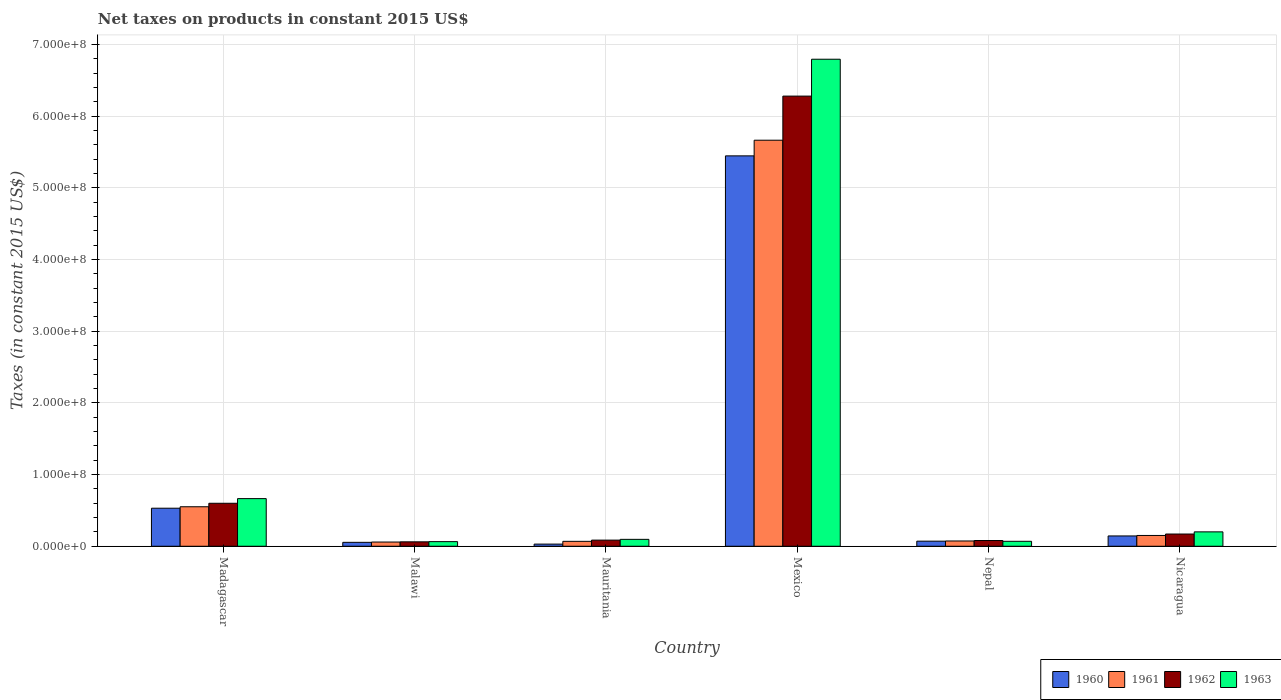How many groups of bars are there?
Your answer should be compact. 6. Are the number of bars per tick equal to the number of legend labels?
Offer a very short reply. Yes. How many bars are there on the 2nd tick from the left?
Give a very brief answer. 4. How many bars are there on the 5th tick from the right?
Keep it short and to the point. 4. What is the label of the 6th group of bars from the left?
Your answer should be compact. Nicaragua. In how many cases, is the number of bars for a given country not equal to the number of legend labels?
Give a very brief answer. 0. What is the net taxes on products in 1962 in Mexico?
Offer a terse response. 6.28e+08. Across all countries, what is the maximum net taxes on products in 1962?
Your answer should be compact. 6.28e+08. Across all countries, what is the minimum net taxes on products in 1963?
Offer a terse response. 6.44e+06. In which country was the net taxes on products in 1961 minimum?
Offer a very short reply. Malawi. What is the total net taxes on products in 1962 in the graph?
Ensure brevity in your answer.  7.28e+08. What is the difference between the net taxes on products in 1961 in Madagascar and that in Mexico?
Make the answer very short. -5.11e+08. What is the difference between the net taxes on products in 1961 in Madagascar and the net taxes on products in 1963 in Malawi?
Give a very brief answer. 4.87e+07. What is the average net taxes on products in 1960 per country?
Provide a succinct answer. 1.05e+08. What is the difference between the net taxes on products of/in 1963 and net taxes on products of/in 1960 in Mauritania?
Keep it short and to the point. 6.63e+06. In how many countries, is the net taxes on products in 1963 greater than 540000000 US$?
Ensure brevity in your answer.  1. What is the ratio of the net taxes on products in 1960 in Malawi to that in Mauritania?
Make the answer very short. 1.82. What is the difference between the highest and the second highest net taxes on products in 1962?
Make the answer very short. 4.29e+07. What is the difference between the highest and the lowest net taxes on products in 1961?
Your answer should be very brief. 5.61e+08. In how many countries, is the net taxes on products in 1962 greater than the average net taxes on products in 1962 taken over all countries?
Offer a very short reply. 1. Is it the case that in every country, the sum of the net taxes on products in 1963 and net taxes on products in 1961 is greater than the sum of net taxes on products in 1962 and net taxes on products in 1960?
Make the answer very short. No. What does the 2nd bar from the left in Mauritania represents?
Your answer should be compact. 1961. What is the difference between two consecutive major ticks on the Y-axis?
Make the answer very short. 1.00e+08. How many legend labels are there?
Offer a very short reply. 4. How are the legend labels stacked?
Your answer should be very brief. Horizontal. What is the title of the graph?
Offer a very short reply. Net taxes on products in constant 2015 US$. What is the label or title of the Y-axis?
Give a very brief answer. Taxes (in constant 2015 US$). What is the Taxes (in constant 2015 US$) in 1960 in Madagascar?
Your response must be concise. 5.31e+07. What is the Taxes (in constant 2015 US$) in 1961 in Madagascar?
Offer a very short reply. 5.51e+07. What is the Taxes (in constant 2015 US$) in 1962 in Madagascar?
Your answer should be compact. 6.00e+07. What is the Taxes (in constant 2015 US$) of 1963 in Madagascar?
Give a very brief answer. 6.64e+07. What is the Taxes (in constant 2015 US$) in 1960 in Malawi?
Provide a short and direct response. 5.46e+06. What is the Taxes (in constant 2015 US$) in 1961 in Malawi?
Offer a very short reply. 5.88e+06. What is the Taxes (in constant 2015 US$) in 1962 in Malawi?
Your response must be concise. 6.16e+06. What is the Taxes (in constant 2015 US$) of 1963 in Malawi?
Your answer should be compact. 6.44e+06. What is the Taxes (in constant 2015 US$) in 1960 in Mauritania?
Provide a short and direct response. 3.00e+06. What is the Taxes (in constant 2015 US$) of 1961 in Mauritania?
Ensure brevity in your answer.  6.85e+06. What is the Taxes (in constant 2015 US$) of 1962 in Mauritania?
Give a very brief answer. 8.56e+06. What is the Taxes (in constant 2015 US$) of 1963 in Mauritania?
Offer a very short reply. 9.63e+06. What is the Taxes (in constant 2015 US$) of 1960 in Mexico?
Offer a very short reply. 5.45e+08. What is the Taxes (in constant 2015 US$) of 1961 in Mexico?
Your response must be concise. 5.66e+08. What is the Taxes (in constant 2015 US$) of 1962 in Mexico?
Your response must be concise. 6.28e+08. What is the Taxes (in constant 2015 US$) in 1963 in Mexico?
Your answer should be very brief. 6.79e+08. What is the Taxes (in constant 2015 US$) in 1960 in Nepal?
Your answer should be very brief. 7.09e+06. What is the Taxes (in constant 2015 US$) of 1961 in Nepal?
Give a very brief answer. 7.35e+06. What is the Taxes (in constant 2015 US$) in 1962 in Nepal?
Provide a succinct answer. 8.01e+06. What is the Taxes (in constant 2015 US$) of 1963 in Nepal?
Offer a very short reply. 6.89e+06. What is the Taxes (in constant 2015 US$) in 1960 in Nicaragua?
Offer a very short reply. 1.44e+07. What is the Taxes (in constant 2015 US$) in 1961 in Nicaragua?
Your answer should be very brief. 1.51e+07. What is the Taxes (in constant 2015 US$) in 1962 in Nicaragua?
Your response must be concise. 1.71e+07. What is the Taxes (in constant 2015 US$) of 1963 in Nicaragua?
Your response must be concise. 2.01e+07. Across all countries, what is the maximum Taxes (in constant 2015 US$) in 1960?
Your response must be concise. 5.45e+08. Across all countries, what is the maximum Taxes (in constant 2015 US$) of 1961?
Keep it short and to the point. 5.66e+08. Across all countries, what is the maximum Taxes (in constant 2015 US$) of 1962?
Your response must be concise. 6.28e+08. Across all countries, what is the maximum Taxes (in constant 2015 US$) of 1963?
Give a very brief answer. 6.79e+08. Across all countries, what is the minimum Taxes (in constant 2015 US$) in 1960?
Make the answer very short. 3.00e+06. Across all countries, what is the minimum Taxes (in constant 2015 US$) in 1961?
Your answer should be compact. 5.88e+06. Across all countries, what is the minimum Taxes (in constant 2015 US$) of 1962?
Offer a very short reply. 6.16e+06. Across all countries, what is the minimum Taxes (in constant 2015 US$) in 1963?
Your answer should be compact. 6.44e+06. What is the total Taxes (in constant 2015 US$) of 1960 in the graph?
Offer a very short reply. 6.28e+08. What is the total Taxes (in constant 2015 US$) of 1961 in the graph?
Ensure brevity in your answer.  6.57e+08. What is the total Taxes (in constant 2015 US$) of 1962 in the graph?
Make the answer very short. 7.28e+08. What is the total Taxes (in constant 2015 US$) in 1963 in the graph?
Provide a succinct answer. 7.89e+08. What is the difference between the Taxes (in constant 2015 US$) of 1960 in Madagascar and that in Malawi?
Your answer should be compact. 4.76e+07. What is the difference between the Taxes (in constant 2015 US$) in 1961 in Madagascar and that in Malawi?
Provide a short and direct response. 4.92e+07. What is the difference between the Taxes (in constant 2015 US$) of 1962 in Madagascar and that in Malawi?
Your response must be concise. 5.38e+07. What is the difference between the Taxes (in constant 2015 US$) in 1963 in Madagascar and that in Malawi?
Your answer should be compact. 6.00e+07. What is the difference between the Taxes (in constant 2015 US$) of 1960 in Madagascar and that in Mauritania?
Keep it short and to the point. 5.01e+07. What is the difference between the Taxes (in constant 2015 US$) of 1961 in Madagascar and that in Mauritania?
Offer a very short reply. 4.82e+07. What is the difference between the Taxes (in constant 2015 US$) in 1962 in Madagascar and that in Mauritania?
Offer a very short reply. 5.14e+07. What is the difference between the Taxes (in constant 2015 US$) in 1963 in Madagascar and that in Mauritania?
Your answer should be very brief. 5.68e+07. What is the difference between the Taxes (in constant 2015 US$) in 1960 in Madagascar and that in Mexico?
Give a very brief answer. -4.91e+08. What is the difference between the Taxes (in constant 2015 US$) in 1961 in Madagascar and that in Mexico?
Your answer should be compact. -5.11e+08. What is the difference between the Taxes (in constant 2015 US$) of 1962 in Madagascar and that in Mexico?
Provide a short and direct response. -5.68e+08. What is the difference between the Taxes (in constant 2015 US$) of 1963 in Madagascar and that in Mexico?
Offer a very short reply. -6.13e+08. What is the difference between the Taxes (in constant 2015 US$) in 1960 in Madagascar and that in Nepal?
Your answer should be compact. 4.60e+07. What is the difference between the Taxes (in constant 2015 US$) in 1961 in Madagascar and that in Nepal?
Give a very brief answer. 4.77e+07. What is the difference between the Taxes (in constant 2015 US$) in 1962 in Madagascar and that in Nepal?
Your answer should be very brief. 5.19e+07. What is the difference between the Taxes (in constant 2015 US$) of 1963 in Madagascar and that in Nepal?
Provide a succinct answer. 5.95e+07. What is the difference between the Taxes (in constant 2015 US$) of 1960 in Madagascar and that in Nicaragua?
Give a very brief answer. 3.87e+07. What is the difference between the Taxes (in constant 2015 US$) in 1961 in Madagascar and that in Nicaragua?
Give a very brief answer. 4.00e+07. What is the difference between the Taxes (in constant 2015 US$) of 1962 in Madagascar and that in Nicaragua?
Offer a terse response. 4.29e+07. What is the difference between the Taxes (in constant 2015 US$) of 1963 in Madagascar and that in Nicaragua?
Your answer should be very brief. 4.64e+07. What is the difference between the Taxes (in constant 2015 US$) in 1960 in Malawi and that in Mauritania?
Your answer should be compact. 2.46e+06. What is the difference between the Taxes (in constant 2015 US$) in 1961 in Malawi and that in Mauritania?
Provide a short and direct response. -9.67e+05. What is the difference between the Taxes (in constant 2015 US$) of 1962 in Malawi and that in Mauritania?
Make the answer very short. -2.40e+06. What is the difference between the Taxes (in constant 2015 US$) of 1963 in Malawi and that in Mauritania?
Offer a very short reply. -3.19e+06. What is the difference between the Taxes (in constant 2015 US$) of 1960 in Malawi and that in Mexico?
Offer a terse response. -5.39e+08. What is the difference between the Taxes (in constant 2015 US$) in 1961 in Malawi and that in Mexico?
Your response must be concise. -5.61e+08. What is the difference between the Taxes (in constant 2015 US$) in 1962 in Malawi and that in Mexico?
Offer a very short reply. -6.22e+08. What is the difference between the Taxes (in constant 2015 US$) in 1963 in Malawi and that in Mexico?
Provide a succinct answer. -6.73e+08. What is the difference between the Taxes (in constant 2015 US$) in 1960 in Malawi and that in Nepal?
Make the answer very short. -1.63e+06. What is the difference between the Taxes (in constant 2015 US$) of 1961 in Malawi and that in Nepal?
Provide a succinct answer. -1.47e+06. What is the difference between the Taxes (in constant 2015 US$) of 1962 in Malawi and that in Nepal?
Provide a succinct answer. -1.85e+06. What is the difference between the Taxes (in constant 2015 US$) in 1963 in Malawi and that in Nepal?
Ensure brevity in your answer.  -4.50e+05. What is the difference between the Taxes (in constant 2015 US$) of 1960 in Malawi and that in Nicaragua?
Offer a terse response. -8.93e+06. What is the difference between the Taxes (in constant 2015 US$) of 1961 in Malawi and that in Nicaragua?
Offer a terse response. -9.18e+06. What is the difference between the Taxes (in constant 2015 US$) of 1962 in Malawi and that in Nicaragua?
Give a very brief answer. -1.09e+07. What is the difference between the Taxes (in constant 2015 US$) in 1963 in Malawi and that in Nicaragua?
Offer a very short reply. -1.36e+07. What is the difference between the Taxes (in constant 2015 US$) of 1960 in Mauritania and that in Mexico?
Provide a short and direct response. -5.42e+08. What is the difference between the Taxes (in constant 2015 US$) of 1961 in Mauritania and that in Mexico?
Keep it short and to the point. -5.60e+08. What is the difference between the Taxes (in constant 2015 US$) of 1962 in Mauritania and that in Mexico?
Your answer should be very brief. -6.19e+08. What is the difference between the Taxes (in constant 2015 US$) in 1963 in Mauritania and that in Mexico?
Offer a very short reply. -6.70e+08. What is the difference between the Taxes (in constant 2015 US$) of 1960 in Mauritania and that in Nepal?
Make the answer very short. -4.09e+06. What is the difference between the Taxes (in constant 2015 US$) in 1961 in Mauritania and that in Nepal?
Provide a succinct answer. -5.03e+05. What is the difference between the Taxes (in constant 2015 US$) of 1962 in Mauritania and that in Nepal?
Give a very brief answer. 5.53e+05. What is the difference between the Taxes (in constant 2015 US$) in 1963 in Mauritania and that in Nepal?
Offer a very short reply. 2.74e+06. What is the difference between the Taxes (in constant 2015 US$) in 1960 in Mauritania and that in Nicaragua?
Provide a succinct answer. -1.14e+07. What is the difference between the Taxes (in constant 2015 US$) of 1961 in Mauritania and that in Nicaragua?
Your answer should be very brief. -8.21e+06. What is the difference between the Taxes (in constant 2015 US$) in 1962 in Mauritania and that in Nicaragua?
Make the answer very short. -8.50e+06. What is the difference between the Taxes (in constant 2015 US$) in 1963 in Mauritania and that in Nicaragua?
Give a very brief answer. -1.04e+07. What is the difference between the Taxes (in constant 2015 US$) of 1960 in Mexico and that in Nepal?
Your answer should be compact. 5.37e+08. What is the difference between the Taxes (in constant 2015 US$) of 1961 in Mexico and that in Nepal?
Offer a very short reply. 5.59e+08. What is the difference between the Taxes (in constant 2015 US$) in 1962 in Mexico and that in Nepal?
Your response must be concise. 6.20e+08. What is the difference between the Taxes (in constant 2015 US$) in 1963 in Mexico and that in Nepal?
Provide a succinct answer. 6.72e+08. What is the difference between the Taxes (in constant 2015 US$) of 1960 in Mexico and that in Nicaragua?
Offer a very short reply. 5.30e+08. What is the difference between the Taxes (in constant 2015 US$) in 1961 in Mexico and that in Nicaragua?
Your response must be concise. 5.51e+08. What is the difference between the Taxes (in constant 2015 US$) in 1962 in Mexico and that in Nicaragua?
Offer a terse response. 6.11e+08. What is the difference between the Taxes (in constant 2015 US$) in 1963 in Mexico and that in Nicaragua?
Offer a terse response. 6.59e+08. What is the difference between the Taxes (in constant 2015 US$) of 1960 in Nepal and that in Nicaragua?
Ensure brevity in your answer.  -7.30e+06. What is the difference between the Taxes (in constant 2015 US$) of 1961 in Nepal and that in Nicaragua?
Your response must be concise. -7.71e+06. What is the difference between the Taxes (in constant 2015 US$) of 1962 in Nepal and that in Nicaragua?
Provide a short and direct response. -9.06e+06. What is the difference between the Taxes (in constant 2015 US$) of 1963 in Nepal and that in Nicaragua?
Your response must be concise. -1.32e+07. What is the difference between the Taxes (in constant 2015 US$) of 1960 in Madagascar and the Taxes (in constant 2015 US$) of 1961 in Malawi?
Your answer should be very brief. 4.72e+07. What is the difference between the Taxes (in constant 2015 US$) of 1960 in Madagascar and the Taxes (in constant 2015 US$) of 1962 in Malawi?
Make the answer very short. 4.69e+07. What is the difference between the Taxes (in constant 2015 US$) in 1960 in Madagascar and the Taxes (in constant 2015 US$) in 1963 in Malawi?
Offer a terse response. 4.66e+07. What is the difference between the Taxes (in constant 2015 US$) of 1961 in Madagascar and the Taxes (in constant 2015 US$) of 1962 in Malawi?
Keep it short and to the point. 4.89e+07. What is the difference between the Taxes (in constant 2015 US$) of 1961 in Madagascar and the Taxes (in constant 2015 US$) of 1963 in Malawi?
Offer a terse response. 4.87e+07. What is the difference between the Taxes (in constant 2015 US$) of 1962 in Madagascar and the Taxes (in constant 2015 US$) of 1963 in Malawi?
Make the answer very short. 5.35e+07. What is the difference between the Taxes (in constant 2015 US$) of 1960 in Madagascar and the Taxes (in constant 2015 US$) of 1961 in Mauritania?
Offer a terse response. 4.62e+07. What is the difference between the Taxes (in constant 2015 US$) of 1960 in Madagascar and the Taxes (in constant 2015 US$) of 1962 in Mauritania?
Make the answer very short. 4.45e+07. What is the difference between the Taxes (in constant 2015 US$) in 1960 in Madagascar and the Taxes (in constant 2015 US$) in 1963 in Mauritania?
Make the answer very short. 4.34e+07. What is the difference between the Taxes (in constant 2015 US$) of 1961 in Madagascar and the Taxes (in constant 2015 US$) of 1962 in Mauritania?
Offer a terse response. 4.65e+07. What is the difference between the Taxes (in constant 2015 US$) of 1961 in Madagascar and the Taxes (in constant 2015 US$) of 1963 in Mauritania?
Your answer should be compact. 4.55e+07. What is the difference between the Taxes (in constant 2015 US$) of 1962 in Madagascar and the Taxes (in constant 2015 US$) of 1963 in Mauritania?
Your answer should be compact. 5.03e+07. What is the difference between the Taxes (in constant 2015 US$) in 1960 in Madagascar and the Taxes (in constant 2015 US$) in 1961 in Mexico?
Your response must be concise. -5.13e+08. What is the difference between the Taxes (in constant 2015 US$) of 1960 in Madagascar and the Taxes (in constant 2015 US$) of 1962 in Mexico?
Your answer should be very brief. -5.75e+08. What is the difference between the Taxes (in constant 2015 US$) in 1960 in Madagascar and the Taxes (in constant 2015 US$) in 1963 in Mexico?
Ensure brevity in your answer.  -6.26e+08. What is the difference between the Taxes (in constant 2015 US$) of 1961 in Madagascar and the Taxes (in constant 2015 US$) of 1962 in Mexico?
Your response must be concise. -5.73e+08. What is the difference between the Taxes (in constant 2015 US$) of 1961 in Madagascar and the Taxes (in constant 2015 US$) of 1963 in Mexico?
Provide a short and direct response. -6.24e+08. What is the difference between the Taxes (in constant 2015 US$) of 1962 in Madagascar and the Taxes (in constant 2015 US$) of 1963 in Mexico?
Make the answer very short. -6.19e+08. What is the difference between the Taxes (in constant 2015 US$) in 1960 in Madagascar and the Taxes (in constant 2015 US$) in 1961 in Nepal?
Offer a terse response. 4.57e+07. What is the difference between the Taxes (in constant 2015 US$) of 1960 in Madagascar and the Taxes (in constant 2015 US$) of 1962 in Nepal?
Offer a very short reply. 4.51e+07. What is the difference between the Taxes (in constant 2015 US$) in 1960 in Madagascar and the Taxes (in constant 2015 US$) in 1963 in Nepal?
Provide a succinct answer. 4.62e+07. What is the difference between the Taxes (in constant 2015 US$) in 1961 in Madagascar and the Taxes (in constant 2015 US$) in 1962 in Nepal?
Offer a very short reply. 4.71e+07. What is the difference between the Taxes (in constant 2015 US$) in 1961 in Madagascar and the Taxes (in constant 2015 US$) in 1963 in Nepal?
Give a very brief answer. 4.82e+07. What is the difference between the Taxes (in constant 2015 US$) in 1962 in Madagascar and the Taxes (in constant 2015 US$) in 1963 in Nepal?
Provide a short and direct response. 5.31e+07. What is the difference between the Taxes (in constant 2015 US$) of 1960 in Madagascar and the Taxes (in constant 2015 US$) of 1961 in Nicaragua?
Offer a terse response. 3.80e+07. What is the difference between the Taxes (in constant 2015 US$) of 1960 in Madagascar and the Taxes (in constant 2015 US$) of 1962 in Nicaragua?
Offer a terse response. 3.60e+07. What is the difference between the Taxes (in constant 2015 US$) of 1960 in Madagascar and the Taxes (in constant 2015 US$) of 1963 in Nicaragua?
Give a very brief answer. 3.30e+07. What is the difference between the Taxes (in constant 2015 US$) in 1961 in Madagascar and the Taxes (in constant 2015 US$) in 1962 in Nicaragua?
Your response must be concise. 3.80e+07. What is the difference between the Taxes (in constant 2015 US$) in 1961 in Madagascar and the Taxes (in constant 2015 US$) in 1963 in Nicaragua?
Keep it short and to the point. 3.50e+07. What is the difference between the Taxes (in constant 2015 US$) of 1962 in Madagascar and the Taxes (in constant 2015 US$) of 1963 in Nicaragua?
Your answer should be compact. 3.99e+07. What is the difference between the Taxes (in constant 2015 US$) in 1960 in Malawi and the Taxes (in constant 2015 US$) in 1961 in Mauritania?
Keep it short and to the point. -1.39e+06. What is the difference between the Taxes (in constant 2015 US$) in 1960 in Malawi and the Taxes (in constant 2015 US$) in 1962 in Mauritania?
Your answer should be compact. -3.10e+06. What is the difference between the Taxes (in constant 2015 US$) in 1960 in Malawi and the Taxes (in constant 2015 US$) in 1963 in Mauritania?
Ensure brevity in your answer.  -4.17e+06. What is the difference between the Taxes (in constant 2015 US$) of 1961 in Malawi and the Taxes (in constant 2015 US$) of 1962 in Mauritania?
Your response must be concise. -2.68e+06. What is the difference between the Taxes (in constant 2015 US$) of 1961 in Malawi and the Taxes (in constant 2015 US$) of 1963 in Mauritania?
Give a very brief answer. -3.75e+06. What is the difference between the Taxes (in constant 2015 US$) in 1962 in Malawi and the Taxes (in constant 2015 US$) in 1963 in Mauritania?
Your answer should be very brief. -3.47e+06. What is the difference between the Taxes (in constant 2015 US$) in 1960 in Malawi and the Taxes (in constant 2015 US$) in 1961 in Mexico?
Offer a terse response. -5.61e+08. What is the difference between the Taxes (in constant 2015 US$) in 1960 in Malawi and the Taxes (in constant 2015 US$) in 1962 in Mexico?
Ensure brevity in your answer.  -6.22e+08. What is the difference between the Taxes (in constant 2015 US$) of 1960 in Malawi and the Taxes (in constant 2015 US$) of 1963 in Mexico?
Offer a terse response. -6.74e+08. What is the difference between the Taxes (in constant 2015 US$) of 1961 in Malawi and the Taxes (in constant 2015 US$) of 1962 in Mexico?
Provide a succinct answer. -6.22e+08. What is the difference between the Taxes (in constant 2015 US$) in 1961 in Malawi and the Taxes (in constant 2015 US$) in 1963 in Mexico?
Make the answer very short. -6.73e+08. What is the difference between the Taxes (in constant 2015 US$) of 1962 in Malawi and the Taxes (in constant 2015 US$) of 1963 in Mexico?
Offer a terse response. -6.73e+08. What is the difference between the Taxes (in constant 2015 US$) of 1960 in Malawi and the Taxes (in constant 2015 US$) of 1961 in Nepal?
Provide a succinct answer. -1.89e+06. What is the difference between the Taxes (in constant 2015 US$) in 1960 in Malawi and the Taxes (in constant 2015 US$) in 1962 in Nepal?
Offer a terse response. -2.55e+06. What is the difference between the Taxes (in constant 2015 US$) of 1960 in Malawi and the Taxes (in constant 2015 US$) of 1963 in Nepal?
Your response must be concise. -1.43e+06. What is the difference between the Taxes (in constant 2015 US$) in 1961 in Malawi and the Taxes (in constant 2015 US$) in 1962 in Nepal?
Provide a short and direct response. -2.13e+06. What is the difference between the Taxes (in constant 2015 US$) of 1961 in Malawi and the Taxes (in constant 2015 US$) of 1963 in Nepal?
Ensure brevity in your answer.  -1.01e+06. What is the difference between the Taxes (in constant 2015 US$) of 1962 in Malawi and the Taxes (in constant 2015 US$) of 1963 in Nepal?
Provide a short and direct response. -7.30e+05. What is the difference between the Taxes (in constant 2015 US$) of 1960 in Malawi and the Taxes (in constant 2015 US$) of 1961 in Nicaragua?
Offer a very short reply. -9.60e+06. What is the difference between the Taxes (in constant 2015 US$) in 1960 in Malawi and the Taxes (in constant 2015 US$) in 1962 in Nicaragua?
Provide a succinct answer. -1.16e+07. What is the difference between the Taxes (in constant 2015 US$) in 1960 in Malawi and the Taxes (in constant 2015 US$) in 1963 in Nicaragua?
Ensure brevity in your answer.  -1.46e+07. What is the difference between the Taxes (in constant 2015 US$) of 1961 in Malawi and the Taxes (in constant 2015 US$) of 1962 in Nicaragua?
Provide a succinct answer. -1.12e+07. What is the difference between the Taxes (in constant 2015 US$) of 1961 in Malawi and the Taxes (in constant 2015 US$) of 1963 in Nicaragua?
Make the answer very short. -1.42e+07. What is the difference between the Taxes (in constant 2015 US$) in 1962 in Malawi and the Taxes (in constant 2015 US$) in 1963 in Nicaragua?
Give a very brief answer. -1.39e+07. What is the difference between the Taxes (in constant 2015 US$) of 1960 in Mauritania and the Taxes (in constant 2015 US$) of 1961 in Mexico?
Make the answer very short. -5.63e+08. What is the difference between the Taxes (in constant 2015 US$) in 1960 in Mauritania and the Taxes (in constant 2015 US$) in 1962 in Mexico?
Offer a very short reply. -6.25e+08. What is the difference between the Taxes (in constant 2015 US$) in 1960 in Mauritania and the Taxes (in constant 2015 US$) in 1963 in Mexico?
Ensure brevity in your answer.  -6.76e+08. What is the difference between the Taxes (in constant 2015 US$) of 1961 in Mauritania and the Taxes (in constant 2015 US$) of 1962 in Mexico?
Make the answer very short. -6.21e+08. What is the difference between the Taxes (in constant 2015 US$) in 1961 in Mauritania and the Taxes (in constant 2015 US$) in 1963 in Mexico?
Give a very brief answer. -6.73e+08. What is the difference between the Taxes (in constant 2015 US$) in 1962 in Mauritania and the Taxes (in constant 2015 US$) in 1963 in Mexico?
Provide a short and direct response. -6.71e+08. What is the difference between the Taxes (in constant 2015 US$) of 1960 in Mauritania and the Taxes (in constant 2015 US$) of 1961 in Nepal?
Keep it short and to the point. -4.35e+06. What is the difference between the Taxes (in constant 2015 US$) in 1960 in Mauritania and the Taxes (in constant 2015 US$) in 1962 in Nepal?
Your answer should be compact. -5.01e+06. What is the difference between the Taxes (in constant 2015 US$) of 1960 in Mauritania and the Taxes (in constant 2015 US$) of 1963 in Nepal?
Your response must be concise. -3.89e+06. What is the difference between the Taxes (in constant 2015 US$) of 1961 in Mauritania and the Taxes (in constant 2015 US$) of 1962 in Nepal?
Provide a short and direct response. -1.16e+06. What is the difference between the Taxes (in constant 2015 US$) of 1961 in Mauritania and the Taxes (in constant 2015 US$) of 1963 in Nepal?
Ensure brevity in your answer.  -4.29e+04. What is the difference between the Taxes (in constant 2015 US$) of 1962 in Mauritania and the Taxes (in constant 2015 US$) of 1963 in Nepal?
Your answer should be compact. 1.67e+06. What is the difference between the Taxes (in constant 2015 US$) in 1960 in Mauritania and the Taxes (in constant 2015 US$) in 1961 in Nicaragua?
Your response must be concise. -1.21e+07. What is the difference between the Taxes (in constant 2015 US$) of 1960 in Mauritania and the Taxes (in constant 2015 US$) of 1962 in Nicaragua?
Offer a terse response. -1.41e+07. What is the difference between the Taxes (in constant 2015 US$) of 1960 in Mauritania and the Taxes (in constant 2015 US$) of 1963 in Nicaragua?
Keep it short and to the point. -1.71e+07. What is the difference between the Taxes (in constant 2015 US$) of 1961 in Mauritania and the Taxes (in constant 2015 US$) of 1962 in Nicaragua?
Provide a succinct answer. -1.02e+07. What is the difference between the Taxes (in constant 2015 US$) in 1961 in Mauritania and the Taxes (in constant 2015 US$) in 1963 in Nicaragua?
Ensure brevity in your answer.  -1.32e+07. What is the difference between the Taxes (in constant 2015 US$) of 1962 in Mauritania and the Taxes (in constant 2015 US$) of 1963 in Nicaragua?
Make the answer very short. -1.15e+07. What is the difference between the Taxes (in constant 2015 US$) of 1960 in Mexico and the Taxes (in constant 2015 US$) of 1961 in Nepal?
Give a very brief answer. 5.37e+08. What is the difference between the Taxes (in constant 2015 US$) in 1960 in Mexico and the Taxes (in constant 2015 US$) in 1962 in Nepal?
Offer a very short reply. 5.37e+08. What is the difference between the Taxes (in constant 2015 US$) in 1960 in Mexico and the Taxes (in constant 2015 US$) in 1963 in Nepal?
Make the answer very short. 5.38e+08. What is the difference between the Taxes (in constant 2015 US$) in 1961 in Mexico and the Taxes (in constant 2015 US$) in 1962 in Nepal?
Offer a very short reply. 5.58e+08. What is the difference between the Taxes (in constant 2015 US$) in 1961 in Mexico and the Taxes (in constant 2015 US$) in 1963 in Nepal?
Make the answer very short. 5.60e+08. What is the difference between the Taxes (in constant 2015 US$) of 1962 in Mexico and the Taxes (in constant 2015 US$) of 1963 in Nepal?
Keep it short and to the point. 6.21e+08. What is the difference between the Taxes (in constant 2015 US$) of 1960 in Mexico and the Taxes (in constant 2015 US$) of 1961 in Nicaragua?
Your answer should be compact. 5.30e+08. What is the difference between the Taxes (in constant 2015 US$) in 1960 in Mexico and the Taxes (in constant 2015 US$) in 1962 in Nicaragua?
Give a very brief answer. 5.28e+08. What is the difference between the Taxes (in constant 2015 US$) of 1960 in Mexico and the Taxes (in constant 2015 US$) of 1963 in Nicaragua?
Ensure brevity in your answer.  5.24e+08. What is the difference between the Taxes (in constant 2015 US$) of 1961 in Mexico and the Taxes (in constant 2015 US$) of 1962 in Nicaragua?
Your answer should be compact. 5.49e+08. What is the difference between the Taxes (in constant 2015 US$) of 1961 in Mexico and the Taxes (in constant 2015 US$) of 1963 in Nicaragua?
Provide a succinct answer. 5.46e+08. What is the difference between the Taxes (in constant 2015 US$) of 1962 in Mexico and the Taxes (in constant 2015 US$) of 1963 in Nicaragua?
Ensure brevity in your answer.  6.08e+08. What is the difference between the Taxes (in constant 2015 US$) of 1960 in Nepal and the Taxes (in constant 2015 US$) of 1961 in Nicaragua?
Your answer should be compact. -7.97e+06. What is the difference between the Taxes (in constant 2015 US$) in 1960 in Nepal and the Taxes (in constant 2015 US$) in 1962 in Nicaragua?
Keep it short and to the point. -9.98e+06. What is the difference between the Taxes (in constant 2015 US$) in 1960 in Nepal and the Taxes (in constant 2015 US$) in 1963 in Nicaragua?
Offer a very short reply. -1.30e+07. What is the difference between the Taxes (in constant 2015 US$) of 1961 in Nepal and the Taxes (in constant 2015 US$) of 1962 in Nicaragua?
Provide a succinct answer. -9.71e+06. What is the difference between the Taxes (in constant 2015 US$) of 1961 in Nepal and the Taxes (in constant 2015 US$) of 1963 in Nicaragua?
Your answer should be very brief. -1.27e+07. What is the difference between the Taxes (in constant 2015 US$) of 1962 in Nepal and the Taxes (in constant 2015 US$) of 1963 in Nicaragua?
Ensure brevity in your answer.  -1.21e+07. What is the average Taxes (in constant 2015 US$) in 1960 per country?
Ensure brevity in your answer.  1.05e+08. What is the average Taxes (in constant 2015 US$) of 1961 per country?
Your answer should be very brief. 1.09e+08. What is the average Taxes (in constant 2015 US$) of 1962 per country?
Ensure brevity in your answer.  1.21e+08. What is the average Taxes (in constant 2015 US$) in 1963 per country?
Make the answer very short. 1.31e+08. What is the difference between the Taxes (in constant 2015 US$) of 1960 and Taxes (in constant 2015 US$) of 1961 in Madagascar?
Your answer should be very brief. -2.03e+06. What is the difference between the Taxes (in constant 2015 US$) of 1960 and Taxes (in constant 2015 US$) of 1962 in Madagascar?
Your answer should be compact. -6.89e+06. What is the difference between the Taxes (in constant 2015 US$) of 1960 and Taxes (in constant 2015 US$) of 1963 in Madagascar?
Your answer should be very brief. -1.34e+07. What is the difference between the Taxes (in constant 2015 US$) of 1961 and Taxes (in constant 2015 US$) of 1962 in Madagascar?
Make the answer very short. -4.86e+06. What is the difference between the Taxes (in constant 2015 US$) of 1961 and Taxes (in constant 2015 US$) of 1963 in Madagascar?
Keep it short and to the point. -1.13e+07. What is the difference between the Taxes (in constant 2015 US$) of 1962 and Taxes (in constant 2015 US$) of 1963 in Madagascar?
Make the answer very short. -6.48e+06. What is the difference between the Taxes (in constant 2015 US$) of 1960 and Taxes (in constant 2015 US$) of 1961 in Malawi?
Offer a terse response. -4.20e+05. What is the difference between the Taxes (in constant 2015 US$) in 1960 and Taxes (in constant 2015 US$) in 1962 in Malawi?
Ensure brevity in your answer.  -7.00e+05. What is the difference between the Taxes (in constant 2015 US$) of 1960 and Taxes (in constant 2015 US$) of 1963 in Malawi?
Provide a succinct answer. -9.80e+05. What is the difference between the Taxes (in constant 2015 US$) in 1961 and Taxes (in constant 2015 US$) in 1962 in Malawi?
Make the answer very short. -2.80e+05. What is the difference between the Taxes (in constant 2015 US$) in 1961 and Taxes (in constant 2015 US$) in 1963 in Malawi?
Provide a short and direct response. -5.60e+05. What is the difference between the Taxes (in constant 2015 US$) in 1962 and Taxes (in constant 2015 US$) in 1963 in Malawi?
Ensure brevity in your answer.  -2.80e+05. What is the difference between the Taxes (in constant 2015 US$) in 1960 and Taxes (in constant 2015 US$) in 1961 in Mauritania?
Keep it short and to the point. -3.85e+06. What is the difference between the Taxes (in constant 2015 US$) of 1960 and Taxes (in constant 2015 US$) of 1962 in Mauritania?
Your response must be concise. -5.56e+06. What is the difference between the Taxes (in constant 2015 US$) of 1960 and Taxes (in constant 2015 US$) of 1963 in Mauritania?
Make the answer very short. -6.63e+06. What is the difference between the Taxes (in constant 2015 US$) of 1961 and Taxes (in constant 2015 US$) of 1962 in Mauritania?
Give a very brief answer. -1.71e+06. What is the difference between the Taxes (in constant 2015 US$) in 1961 and Taxes (in constant 2015 US$) in 1963 in Mauritania?
Your response must be concise. -2.78e+06. What is the difference between the Taxes (in constant 2015 US$) of 1962 and Taxes (in constant 2015 US$) of 1963 in Mauritania?
Give a very brief answer. -1.07e+06. What is the difference between the Taxes (in constant 2015 US$) in 1960 and Taxes (in constant 2015 US$) in 1961 in Mexico?
Provide a short and direct response. -2.18e+07. What is the difference between the Taxes (in constant 2015 US$) of 1960 and Taxes (in constant 2015 US$) of 1962 in Mexico?
Your answer should be very brief. -8.34e+07. What is the difference between the Taxes (in constant 2015 US$) of 1960 and Taxes (in constant 2015 US$) of 1963 in Mexico?
Provide a succinct answer. -1.35e+08. What is the difference between the Taxes (in constant 2015 US$) in 1961 and Taxes (in constant 2015 US$) in 1962 in Mexico?
Give a very brief answer. -6.15e+07. What is the difference between the Taxes (in constant 2015 US$) in 1961 and Taxes (in constant 2015 US$) in 1963 in Mexico?
Offer a terse response. -1.13e+08. What is the difference between the Taxes (in constant 2015 US$) in 1962 and Taxes (in constant 2015 US$) in 1963 in Mexico?
Make the answer very short. -5.14e+07. What is the difference between the Taxes (in constant 2015 US$) in 1960 and Taxes (in constant 2015 US$) in 1961 in Nepal?
Give a very brief answer. -2.63e+05. What is the difference between the Taxes (in constant 2015 US$) of 1960 and Taxes (in constant 2015 US$) of 1962 in Nepal?
Offer a terse response. -9.19e+05. What is the difference between the Taxes (in constant 2015 US$) in 1960 and Taxes (in constant 2015 US$) in 1963 in Nepal?
Ensure brevity in your answer.  1.97e+05. What is the difference between the Taxes (in constant 2015 US$) of 1961 and Taxes (in constant 2015 US$) of 1962 in Nepal?
Ensure brevity in your answer.  -6.56e+05. What is the difference between the Taxes (in constant 2015 US$) of 1961 and Taxes (in constant 2015 US$) of 1963 in Nepal?
Make the answer very short. 4.60e+05. What is the difference between the Taxes (in constant 2015 US$) of 1962 and Taxes (in constant 2015 US$) of 1963 in Nepal?
Provide a short and direct response. 1.12e+06. What is the difference between the Taxes (in constant 2015 US$) in 1960 and Taxes (in constant 2015 US$) in 1961 in Nicaragua?
Your response must be concise. -6.69e+05. What is the difference between the Taxes (in constant 2015 US$) in 1960 and Taxes (in constant 2015 US$) in 1962 in Nicaragua?
Your answer should be very brief. -2.68e+06. What is the difference between the Taxes (in constant 2015 US$) of 1960 and Taxes (in constant 2015 US$) of 1963 in Nicaragua?
Your answer should be very brief. -5.69e+06. What is the difference between the Taxes (in constant 2015 US$) of 1961 and Taxes (in constant 2015 US$) of 1962 in Nicaragua?
Offer a very short reply. -2.01e+06. What is the difference between the Taxes (in constant 2015 US$) of 1961 and Taxes (in constant 2015 US$) of 1963 in Nicaragua?
Your answer should be very brief. -5.02e+06. What is the difference between the Taxes (in constant 2015 US$) of 1962 and Taxes (in constant 2015 US$) of 1963 in Nicaragua?
Make the answer very short. -3.01e+06. What is the ratio of the Taxes (in constant 2015 US$) of 1960 in Madagascar to that in Malawi?
Give a very brief answer. 9.72. What is the ratio of the Taxes (in constant 2015 US$) in 1961 in Madagascar to that in Malawi?
Make the answer very short. 9.37. What is the ratio of the Taxes (in constant 2015 US$) in 1962 in Madagascar to that in Malawi?
Provide a succinct answer. 9.73. What is the ratio of the Taxes (in constant 2015 US$) in 1963 in Madagascar to that in Malawi?
Ensure brevity in your answer.  10.32. What is the ratio of the Taxes (in constant 2015 US$) in 1960 in Madagascar to that in Mauritania?
Offer a very short reply. 17.72. What is the ratio of the Taxes (in constant 2015 US$) in 1961 in Madagascar to that in Mauritania?
Your response must be concise. 8.05. What is the ratio of the Taxes (in constant 2015 US$) of 1962 in Madagascar to that in Mauritania?
Make the answer very short. 7. What is the ratio of the Taxes (in constant 2015 US$) of 1963 in Madagascar to that in Mauritania?
Provide a short and direct response. 6.9. What is the ratio of the Taxes (in constant 2015 US$) in 1960 in Madagascar to that in Mexico?
Your answer should be compact. 0.1. What is the ratio of the Taxes (in constant 2015 US$) in 1961 in Madagascar to that in Mexico?
Keep it short and to the point. 0.1. What is the ratio of the Taxes (in constant 2015 US$) in 1962 in Madagascar to that in Mexico?
Your answer should be compact. 0.1. What is the ratio of the Taxes (in constant 2015 US$) of 1963 in Madagascar to that in Mexico?
Ensure brevity in your answer.  0.1. What is the ratio of the Taxes (in constant 2015 US$) in 1960 in Madagascar to that in Nepal?
Your answer should be very brief. 7.49. What is the ratio of the Taxes (in constant 2015 US$) in 1961 in Madagascar to that in Nepal?
Offer a terse response. 7.5. What is the ratio of the Taxes (in constant 2015 US$) of 1962 in Madagascar to that in Nepal?
Your response must be concise. 7.49. What is the ratio of the Taxes (in constant 2015 US$) of 1963 in Madagascar to that in Nepal?
Your answer should be compact. 9.64. What is the ratio of the Taxes (in constant 2015 US$) in 1960 in Madagascar to that in Nicaragua?
Offer a terse response. 3.69. What is the ratio of the Taxes (in constant 2015 US$) of 1961 in Madagascar to that in Nicaragua?
Ensure brevity in your answer.  3.66. What is the ratio of the Taxes (in constant 2015 US$) in 1962 in Madagascar to that in Nicaragua?
Offer a terse response. 3.51. What is the ratio of the Taxes (in constant 2015 US$) of 1963 in Madagascar to that in Nicaragua?
Offer a terse response. 3.31. What is the ratio of the Taxes (in constant 2015 US$) of 1960 in Malawi to that in Mauritania?
Your answer should be compact. 1.82. What is the ratio of the Taxes (in constant 2015 US$) of 1961 in Malawi to that in Mauritania?
Provide a succinct answer. 0.86. What is the ratio of the Taxes (in constant 2015 US$) of 1962 in Malawi to that in Mauritania?
Offer a terse response. 0.72. What is the ratio of the Taxes (in constant 2015 US$) of 1963 in Malawi to that in Mauritania?
Provide a succinct answer. 0.67. What is the ratio of the Taxes (in constant 2015 US$) in 1961 in Malawi to that in Mexico?
Your answer should be compact. 0.01. What is the ratio of the Taxes (in constant 2015 US$) in 1962 in Malawi to that in Mexico?
Keep it short and to the point. 0.01. What is the ratio of the Taxes (in constant 2015 US$) of 1963 in Malawi to that in Mexico?
Make the answer very short. 0.01. What is the ratio of the Taxes (in constant 2015 US$) of 1960 in Malawi to that in Nepal?
Make the answer very short. 0.77. What is the ratio of the Taxes (in constant 2015 US$) of 1962 in Malawi to that in Nepal?
Your answer should be compact. 0.77. What is the ratio of the Taxes (in constant 2015 US$) in 1963 in Malawi to that in Nepal?
Make the answer very short. 0.93. What is the ratio of the Taxes (in constant 2015 US$) in 1960 in Malawi to that in Nicaragua?
Your response must be concise. 0.38. What is the ratio of the Taxes (in constant 2015 US$) in 1961 in Malawi to that in Nicaragua?
Offer a terse response. 0.39. What is the ratio of the Taxes (in constant 2015 US$) of 1962 in Malawi to that in Nicaragua?
Provide a succinct answer. 0.36. What is the ratio of the Taxes (in constant 2015 US$) of 1963 in Malawi to that in Nicaragua?
Ensure brevity in your answer.  0.32. What is the ratio of the Taxes (in constant 2015 US$) of 1960 in Mauritania to that in Mexico?
Your response must be concise. 0.01. What is the ratio of the Taxes (in constant 2015 US$) of 1961 in Mauritania to that in Mexico?
Give a very brief answer. 0.01. What is the ratio of the Taxes (in constant 2015 US$) in 1962 in Mauritania to that in Mexico?
Provide a short and direct response. 0.01. What is the ratio of the Taxes (in constant 2015 US$) of 1963 in Mauritania to that in Mexico?
Your response must be concise. 0.01. What is the ratio of the Taxes (in constant 2015 US$) in 1960 in Mauritania to that in Nepal?
Offer a very short reply. 0.42. What is the ratio of the Taxes (in constant 2015 US$) in 1961 in Mauritania to that in Nepal?
Keep it short and to the point. 0.93. What is the ratio of the Taxes (in constant 2015 US$) in 1962 in Mauritania to that in Nepal?
Provide a short and direct response. 1.07. What is the ratio of the Taxes (in constant 2015 US$) in 1963 in Mauritania to that in Nepal?
Your answer should be very brief. 1.4. What is the ratio of the Taxes (in constant 2015 US$) of 1960 in Mauritania to that in Nicaragua?
Offer a terse response. 0.21. What is the ratio of the Taxes (in constant 2015 US$) of 1961 in Mauritania to that in Nicaragua?
Offer a very short reply. 0.45. What is the ratio of the Taxes (in constant 2015 US$) in 1962 in Mauritania to that in Nicaragua?
Keep it short and to the point. 0.5. What is the ratio of the Taxes (in constant 2015 US$) of 1963 in Mauritania to that in Nicaragua?
Provide a short and direct response. 0.48. What is the ratio of the Taxes (in constant 2015 US$) in 1960 in Mexico to that in Nepal?
Your response must be concise. 76.83. What is the ratio of the Taxes (in constant 2015 US$) in 1961 in Mexico to that in Nepal?
Ensure brevity in your answer.  77.06. What is the ratio of the Taxes (in constant 2015 US$) in 1962 in Mexico to that in Nepal?
Provide a succinct answer. 78.43. What is the ratio of the Taxes (in constant 2015 US$) in 1963 in Mexico to that in Nepal?
Your answer should be very brief. 98.6. What is the ratio of the Taxes (in constant 2015 US$) in 1960 in Mexico to that in Nicaragua?
Ensure brevity in your answer.  37.85. What is the ratio of the Taxes (in constant 2015 US$) of 1961 in Mexico to that in Nicaragua?
Your response must be concise. 37.62. What is the ratio of the Taxes (in constant 2015 US$) in 1962 in Mexico to that in Nicaragua?
Offer a terse response. 36.8. What is the ratio of the Taxes (in constant 2015 US$) in 1963 in Mexico to that in Nicaragua?
Give a very brief answer. 33.84. What is the ratio of the Taxes (in constant 2015 US$) of 1960 in Nepal to that in Nicaragua?
Make the answer very short. 0.49. What is the ratio of the Taxes (in constant 2015 US$) of 1961 in Nepal to that in Nicaragua?
Ensure brevity in your answer.  0.49. What is the ratio of the Taxes (in constant 2015 US$) in 1962 in Nepal to that in Nicaragua?
Give a very brief answer. 0.47. What is the ratio of the Taxes (in constant 2015 US$) of 1963 in Nepal to that in Nicaragua?
Offer a very short reply. 0.34. What is the difference between the highest and the second highest Taxes (in constant 2015 US$) of 1960?
Offer a terse response. 4.91e+08. What is the difference between the highest and the second highest Taxes (in constant 2015 US$) of 1961?
Keep it short and to the point. 5.11e+08. What is the difference between the highest and the second highest Taxes (in constant 2015 US$) of 1962?
Make the answer very short. 5.68e+08. What is the difference between the highest and the second highest Taxes (in constant 2015 US$) of 1963?
Provide a short and direct response. 6.13e+08. What is the difference between the highest and the lowest Taxes (in constant 2015 US$) of 1960?
Provide a succinct answer. 5.42e+08. What is the difference between the highest and the lowest Taxes (in constant 2015 US$) in 1961?
Keep it short and to the point. 5.61e+08. What is the difference between the highest and the lowest Taxes (in constant 2015 US$) in 1962?
Provide a short and direct response. 6.22e+08. What is the difference between the highest and the lowest Taxes (in constant 2015 US$) of 1963?
Offer a very short reply. 6.73e+08. 